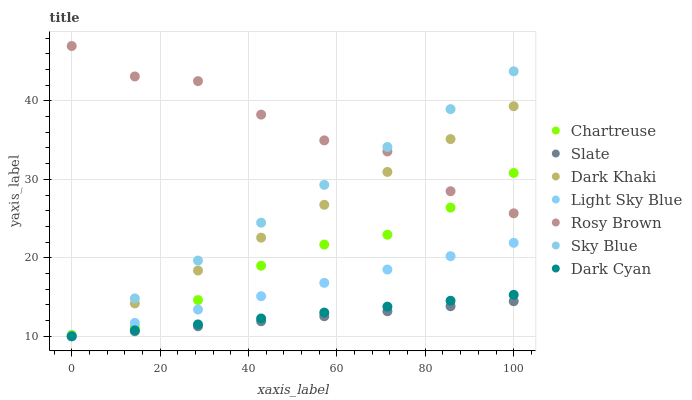Does Slate have the minimum area under the curve?
Answer yes or no. Yes. Does Rosy Brown have the maximum area under the curve?
Answer yes or no. Yes. Does Dark Khaki have the minimum area under the curve?
Answer yes or no. No. Does Dark Khaki have the maximum area under the curve?
Answer yes or no. No. Is Dark Cyan the smoothest?
Answer yes or no. Yes. Is Rosy Brown the roughest?
Answer yes or no. Yes. Is Dark Khaki the smoothest?
Answer yes or no. No. Is Dark Khaki the roughest?
Answer yes or no. No. Does Slate have the lowest value?
Answer yes or no. Yes. Does Rosy Brown have the lowest value?
Answer yes or no. No. Does Rosy Brown have the highest value?
Answer yes or no. Yes. Does Dark Khaki have the highest value?
Answer yes or no. No. Is Slate less than Chartreuse?
Answer yes or no. Yes. Is Chartreuse greater than Dark Cyan?
Answer yes or no. Yes. Does Chartreuse intersect Light Sky Blue?
Answer yes or no. Yes. Is Chartreuse less than Light Sky Blue?
Answer yes or no. No. Is Chartreuse greater than Light Sky Blue?
Answer yes or no. No. Does Slate intersect Chartreuse?
Answer yes or no. No. 